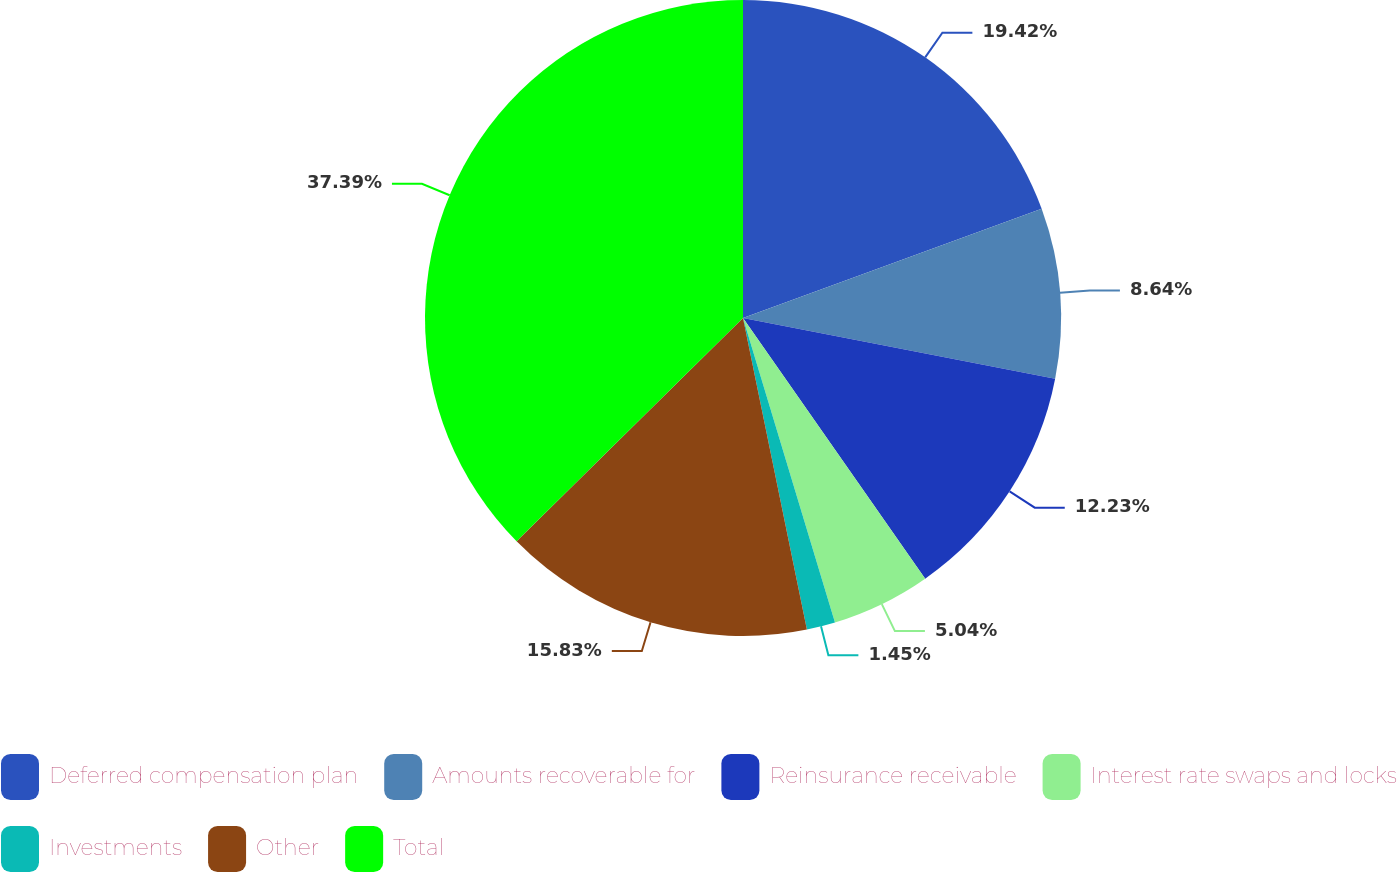Convert chart. <chart><loc_0><loc_0><loc_500><loc_500><pie_chart><fcel>Deferred compensation plan<fcel>Amounts recoverable for<fcel>Reinsurance receivable<fcel>Interest rate swaps and locks<fcel>Investments<fcel>Other<fcel>Total<nl><fcel>19.42%<fcel>8.64%<fcel>12.23%<fcel>5.04%<fcel>1.45%<fcel>15.83%<fcel>37.39%<nl></chart> 